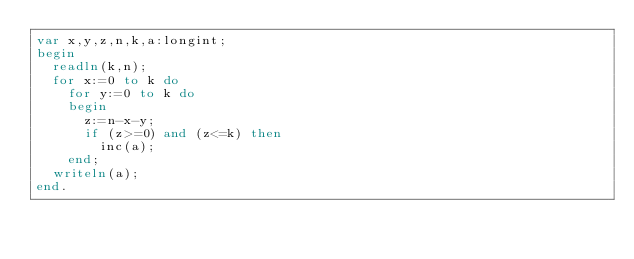<code> <loc_0><loc_0><loc_500><loc_500><_Pascal_>var x,y,z,n,k,a:longint;
begin
  readln(k,n);
  for x:=0 to k do
    for y:=0 to k do
    begin
      z:=n-x-y;
      if (z>=0) and (z<=k) then
        inc(a);
    end;
  writeln(a);
end.</code> 